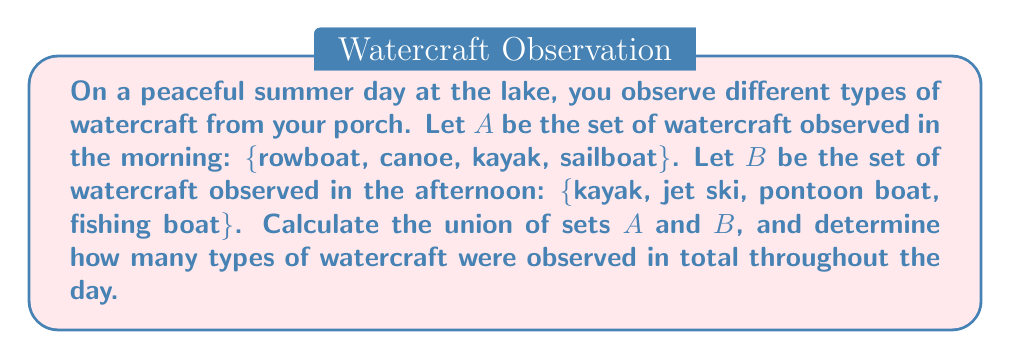Can you answer this question? To solve this problem, we need to understand the concept of union in set theory and follow these steps:

1. Identify the elements in each set:
   Set A = {rowboat, canoe, kayak, sailboat}
   Set B = {kayak, jet ski, pontoon boat, fishing boat}

2. The union of two sets A and B, denoted as $A \cup B$, is the set of all elements that are in A, or in B, or in both A and B.

3. To find $A \cup B$, we list all unique elements from both sets:
   $A \cup B$ = {rowboat, canoe, kayak, sailboat, jet ski, pontoon boat, fishing boat}

4. Note that "kayak" appears in both sets, but we only include it once in the union.

5. To determine the total number of types of watercraft observed, we count the elements in the union set:
   $|A \cup B| = 7$

Therefore, 7 different types of watercraft were observed throughout the day.

The formula for the number of elements in a union of two sets is:
$$|A \cup B| = |A| + |B| - |A \cap B|$$

Where $|A \cap B|$ represents the number of elements common to both sets.

In this case:
$|A| = 4$, $|B| = 4$, and $|A \cap B| = 1$ (kayak)

We can verify our result:
$$|A \cup B| = 4 + 4 - 1 = 7$$
Answer: The union of sets A and B is {rowboat, canoe, kayak, sailboat, jet ski, pontoon boat, fishing boat}. A total of 7 different types of watercraft were observed throughout the day. 